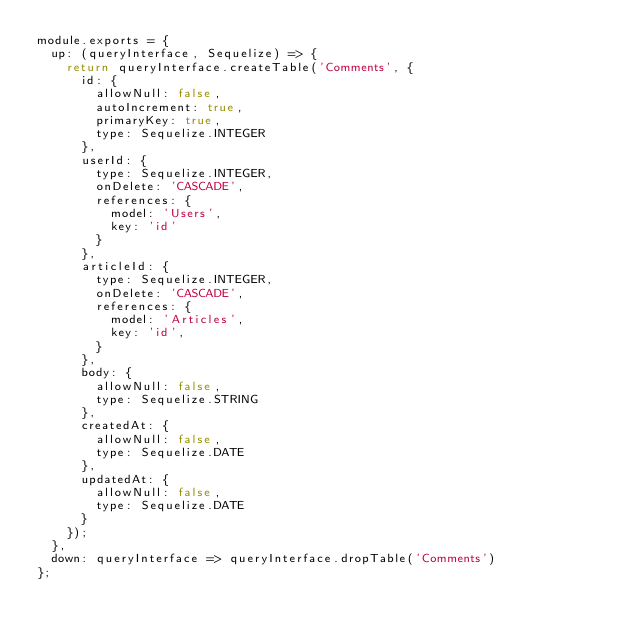Convert code to text. <code><loc_0><loc_0><loc_500><loc_500><_JavaScript_>module.exports = {
  up: (queryInterface, Sequelize) => {
    return queryInterface.createTable('Comments', {
      id: {
        allowNull: false,
        autoIncrement: true,
        primaryKey: true,
        type: Sequelize.INTEGER
      },
      userId: {
        type: Sequelize.INTEGER,
        onDelete: 'CASCADE',
        references: {
          model: 'Users',
          key: 'id'
        }
      },
      articleId: {
        type: Sequelize.INTEGER,
        onDelete: 'CASCADE',
        references: {
          model: 'Articles',
          key: 'id',
        }
      },
      body: {
        allowNull: false,
        type: Sequelize.STRING
      },
      createdAt: {
        allowNull: false,
        type: Sequelize.DATE
      },
      updatedAt: {
        allowNull: false,
        type: Sequelize.DATE
      }
    });
  },
  down: queryInterface => queryInterface.dropTable('Comments')
};
</code> 